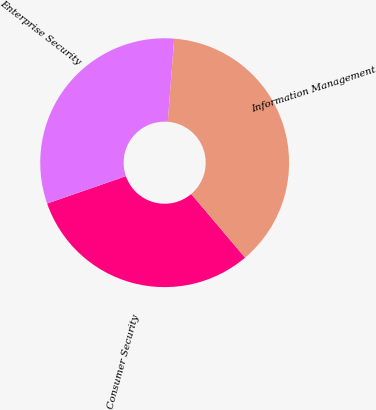Convert chart. <chart><loc_0><loc_0><loc_500><loc_500><pie_chart><fcel>Consumer Security<fcel>Enterprise Security<fcel>Information Management<nl><fcel>30.86%<fcel>31.54%<fcel>37.6%<nl></chart> 